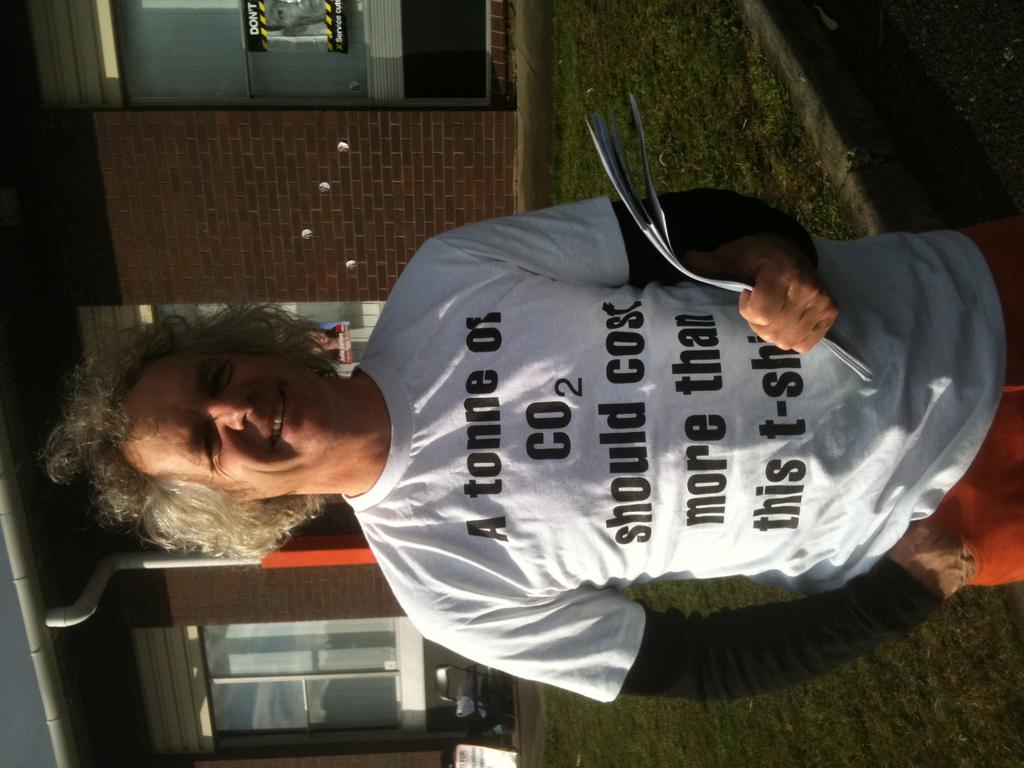What is the main subject of the image? There is a man standing in the middle of the image. What is the man doing in the image? The man is smiling and holding some papers. What can be seen in the background of the image? There is a building in the background of the image, and there is a poster on the building. What type of natural environment is visible in the image? There is grass visible in the image. Can you see any pigs or waves in the image? No, there are no pigs or waves present in the image. Is there a mountain visible in the image? No, there is no mountain visible in the image. 